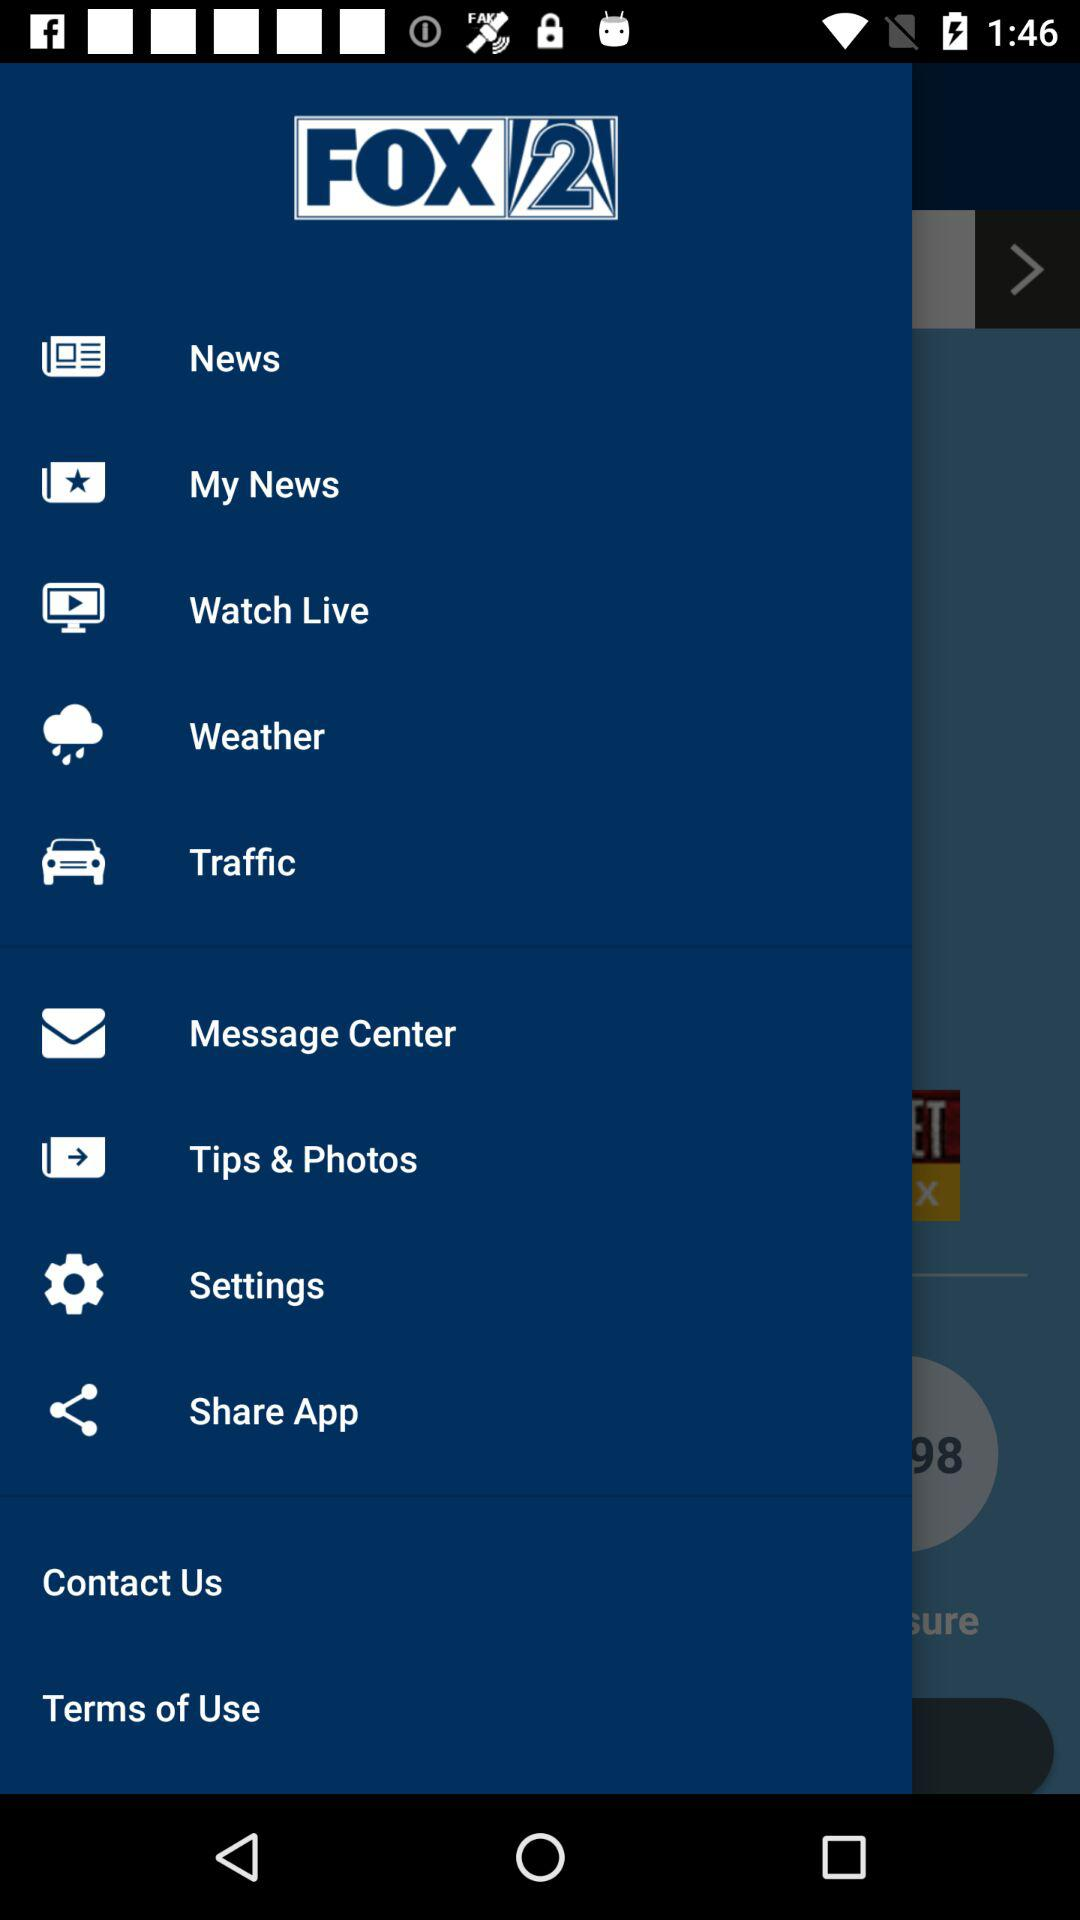What is the application name? The application name is "FOX 2". 